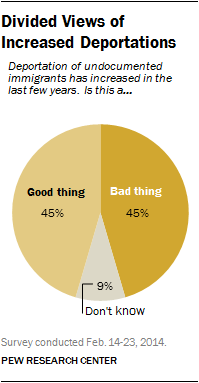Highlight a few significant elements in this photo. The ratio of the two largest segments (A:B) is 0.042361111... It is not clear what you are asking. Could you please provide more context or clarify your question? 